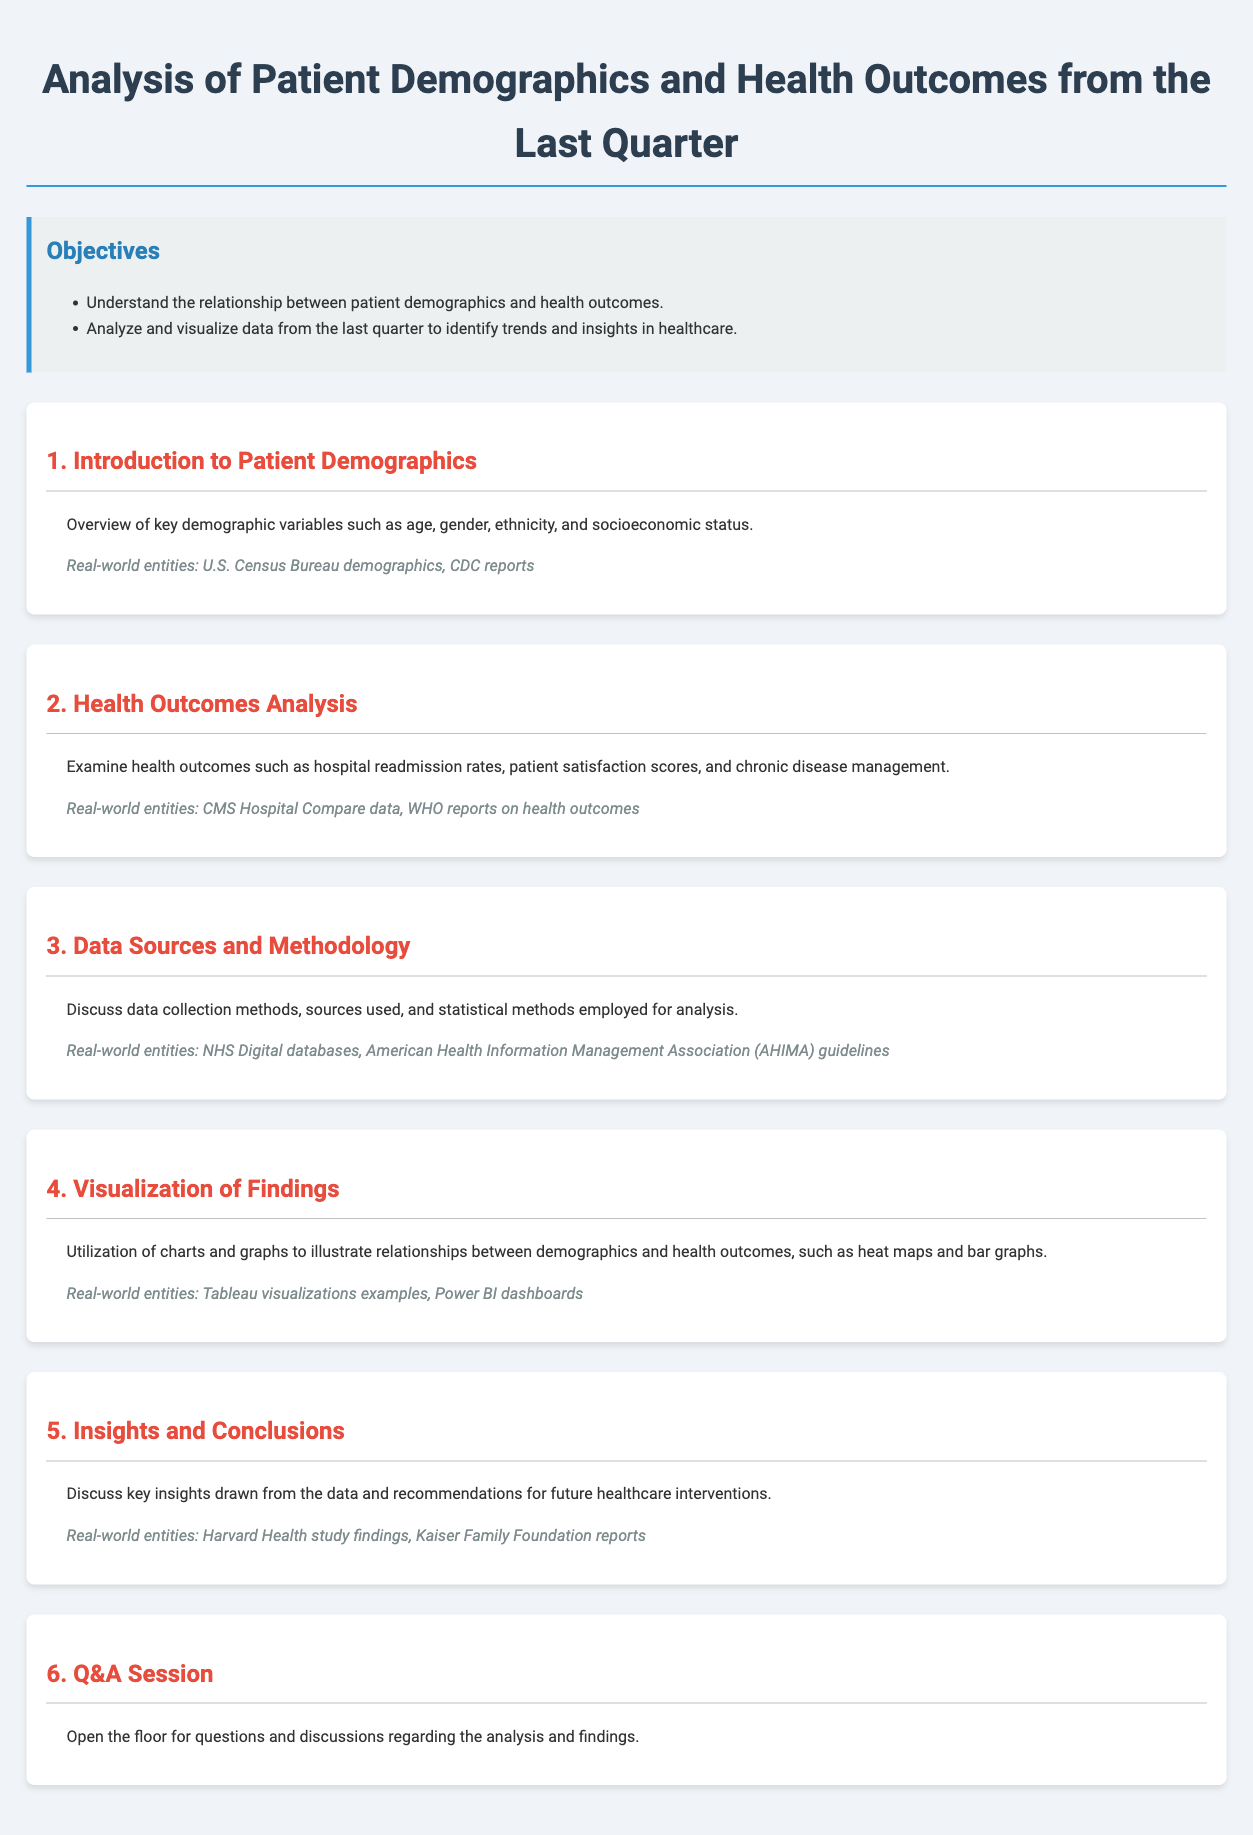what is the title of the document? The title of the document is specified at the top of the rendered HTML as "Analysis of Patient Demographics and Health Outcomes from the Last Quarter."
Answer: Analysis of Patient Demographics and Health Outcomes from the Last Quarter what is the first objective listed? The objectives are specified in the "Objectives" section, and the first objective is to understand the relationship between patient demographics and health outcomes.
Answer: Understand the relationship between patient demographics and health outcomes how many sections are in the document? The document is divided into 6 sections, each focused on different aspects of the analysis.
Answer: 6 what type of data sources are mentioned in section 3? Section 3 discusses data sources and methodology, mentioning NHS Digital databases and AHIMA guidelines as examples.
Answer: NHS Digital databases, AHIMA guidelines what visualizations are utilized to illustrate findings? Section 4 details the types of visualizations used, which include heat maps and bar graphs.
Answer: Heat maps and bar graphs what is a key insight derived from the analysis? The concluding section discusses key insights and recommendations but does not specify a number or value. It suggests drawing insights from the analysis without specific examples.
Answer: Key insights drawn from the data what does the Q&A session entail? The Q&A session is specifically mentioned to open the floor for questions and discussions regarding the analysis and findings.
Answer: Questions and discussions regarding the analysis and findings 